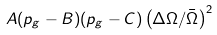<formula> <loc_0><loc_0><loc_500><loc_500>A ( p _ { g } - B ) ( p _ { g } - C ) \left ( \Delta \Omega / \bar { \Omega } \right ) ^ { 2 }</formula> 